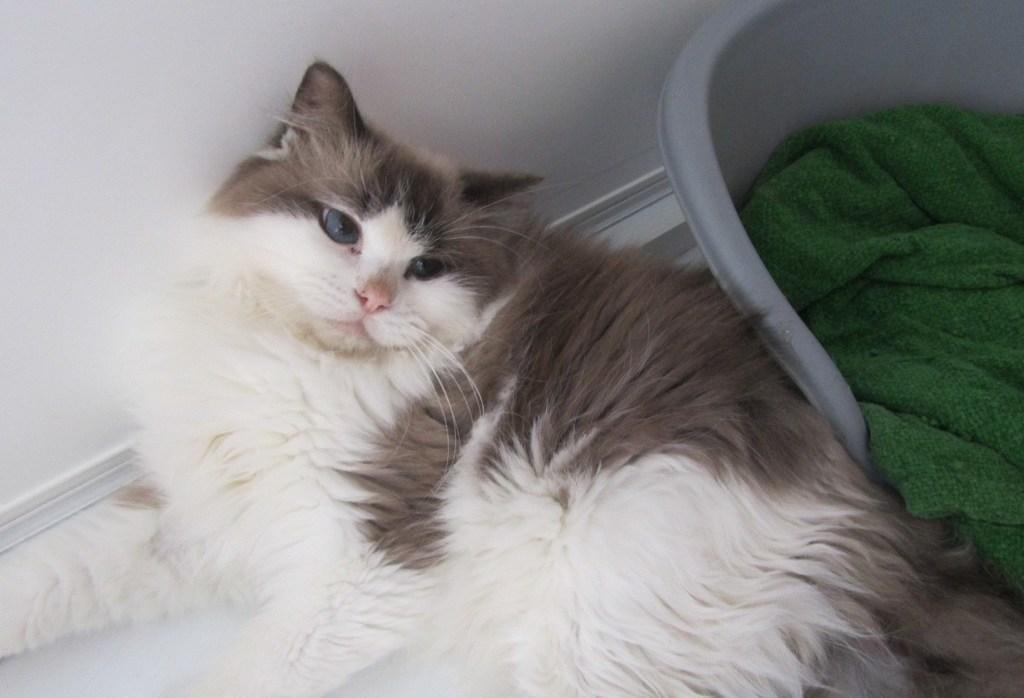Could you give a brief overview of what you see in this image? In this image we can see a cat lying on the floor. In the background there are wall and a towel. 